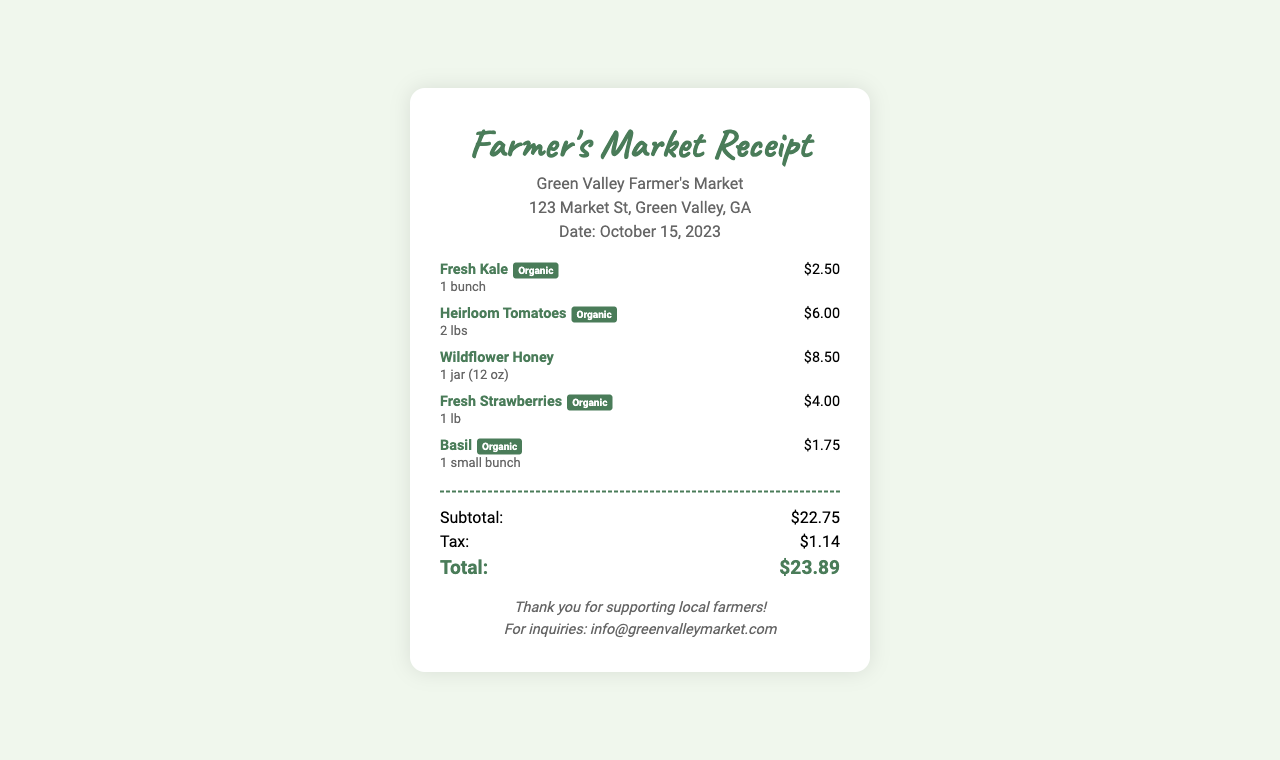What is the name of the market? The name of the market is presented at the top of the receipt.
Answer: Green Valley Farmer's Market What is the date of the purchase? The date is included in the header of the receipt.
Answer: October 15, 2023 How much did the fresh strawberries cost? The price for the fresh strawberries is stated next to the item on the receipt.
Answer: $4.00 How many pounds of heirloom tomatoes were purchased? The quantity is specified in the purchase details of the heirloom tomatoes.
Answer: 2 lbs What is the total amount due on the receipt? The total amount is calculated at the bottom of the receipt.
Answer: $23.89 Which item is organic and has the highest price? The items are labeled, and their prices can be compared to determine the highest-priced organic item.
Answer: Wildflower Honey How much tax was applied to the purchase? The tax is detailed in the summary section of the receipt.
Answer: $1.14 What is the quantity of fresh kale purchased? The quantity for fresh kale is listed next to the item in the purchase section.
Answer: 1 bunch What type of honey is included in the purchase? The type of honey is specified in the purchase description.
Answer: Wildflower Honey 